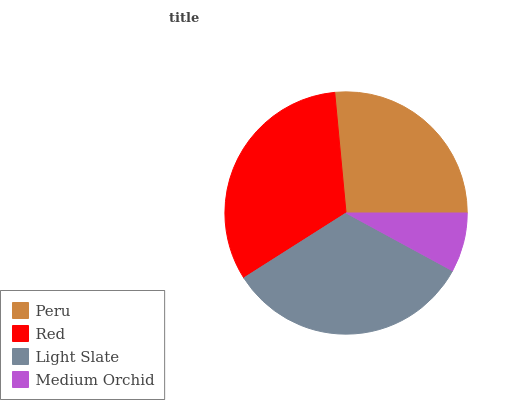Is Medium Orchid the minimum?
Answer yes or no. Yes. Is Light Slate the maximum?
Answer yes or no. Yes. Is Red the minimum?
Answer yes or no. No. Is Red the maximum?
Answer yes or no. No. Is Red greater than Peru?
Answer yes or no. Yes. Is Peru less than Red?
Answer yes or no. Yes. Is Peru greater than Red?
Answer yes or no. No. Is Red less than Peru?
Answer yes or no. No. Is Red the high median?
Answer yes or no. Yes. Is Peru the low median?
Answer yes or no. Yes. Is Medium Orchid the high median?
Answer yes or no. No. Is Red the low median?
Answer yes or no. No. 